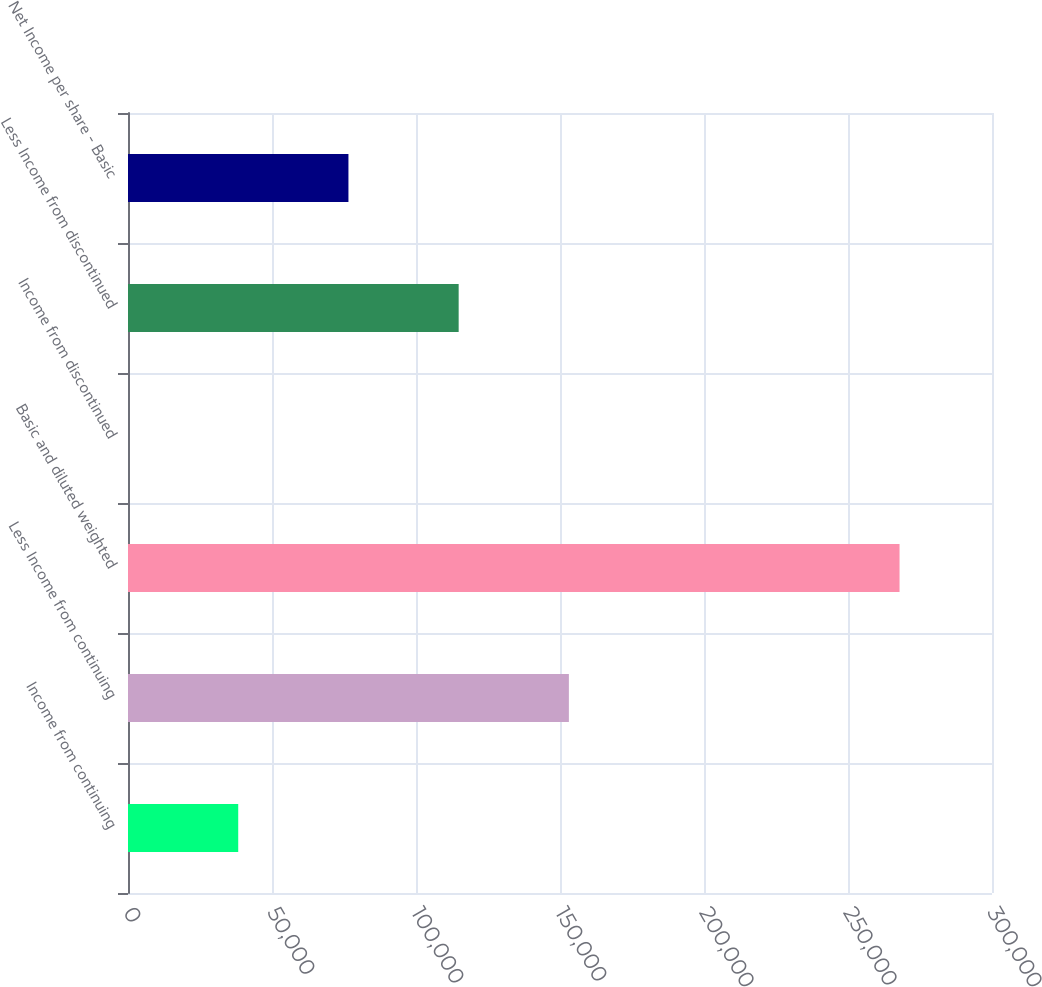<chart> <loc_0><loc_0><loc_500><loc_500><bar_chart><fcel>Income from continuing<fcel>Less Income from continuing<fcel>Basic and diluted weighted<fcel>Income from discontinued<fcel>Less Income from discontinued<fcel>Net Income per share - Basic<nl><fcel>38271.2<fcel>153084<fcel>267898<fcel>0.13<fcel>114813<fcel>76542.3<nl></chart> 